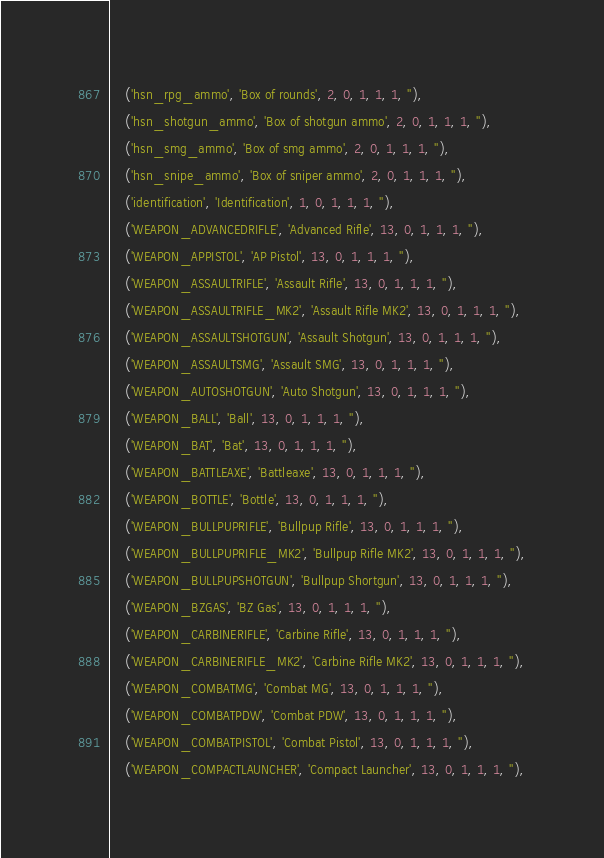<code> <loc_0><loc_0><loc_500><loc_500><_SQL_>	('hsn_rpg_ammo', 'Box of rounds', 2, 0, 1, 1, 1, ''),
	('hsn_shotgun_ammo', 'Box of shotgun ammo', 2, 0, 1, 1, 1, ''),
	('hsn_smg_ammo', 'Box of smg ammo', 2, 0, 1, 1, 1, ''),
	('hsn_snipe_ammo', 'Box of sniper ammo', 2, 0, 1, 1, 1, ''),
	('identification', 'Identification', 1, 0, 1, 1, 1, ''),
	('WEAPON_ADVANCEDRIFLE', 'Advanced Rifle', 13, 0, 1, 1, 1, ''),
	('WEAPON_APPISTOL', 'AP Pistol', 13, 0, 1, 1, 1, ''),
	('WEAPON_ASSAULTRIFLE', 'Assault Rifle', 13, 0, 1, 1, 1, ''),
	('WEAPON_ASSAULTRIFLE_MK2', 'Assault Rifle MK2', 13, 0, 1, 1, 1, ''),
	('WEAPON_ASSAULTSHOTGUN', 'Assault Shotgun', 13, 0, 1, 1, 1, ''),
	('WEAPON_ASSAULTSMG', 'Assault SMG', 13, 0, 1, 1, 1, ''),
	('WEAPON_AUTOSHOTGUN', 'Auto Shotgun', 13, 0, 1, 1, 1, ''),
	('WEAPON_BALL', 'Ball', 13, 0, 1, 1, 1, ''),
	('WEAPON_BAT', 'Bat', 13, 0, 1, 1, 1, ''),
	('WEAPON_BATTLEAXE', 'Battleaxe', 13, 0, 1, 1, 1, ''),
	('WEAPON_BOTTLE', 'Bottle', 13, 0, 1, 1, 1, ''),
	('WEAPON_BULLPUPRIFLE', 'Bullpup Rifle', 13, 0, 1, 1, 1, ''),
	('WEAPON_BULLPUPRIFLE_MK2', 'Bullpup Rifle MK2', 13, 0, 1, 1, 1, ''),
	('WEAPON_BULLPUPSHOTGUN', 'Bullpup Shortgun', 13, 0, 1, 1, 1, ''),
	('WEAPON_BZGAS', 'BZ Gas', 13, 0, 1, 1, 1, ''),
	('WEAPON_CARBINERIFLE', 'Carbine Rifle', 13, 0, 1, 1, 1, ''),
	('WEAPON_CARBINERIFLE_MK2', 'Carbine Rifle MK2', 13, 0, 1, 1, 1, ''),
	('WEAPON_COMBATMG', 'Combat MG', 13, 0, 1, 1, 1, ''),
	('WEAPON_COMBATPDW', 'Combat PDW', 13, 0, 1, 1, 1, ''),
	('WEAPON_COMBATPISTOL', 'Combat Pistol', 13, 0, 1, 1, 1, ''),
	('WEAPON_COMPACTLAUNCHER', 'Compact Launcher', 13, 0, 1, 1, 1, ''),</code> 